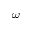<formula> <loc_0><loc_0><loc_500><loc_500>\omega</formula> 